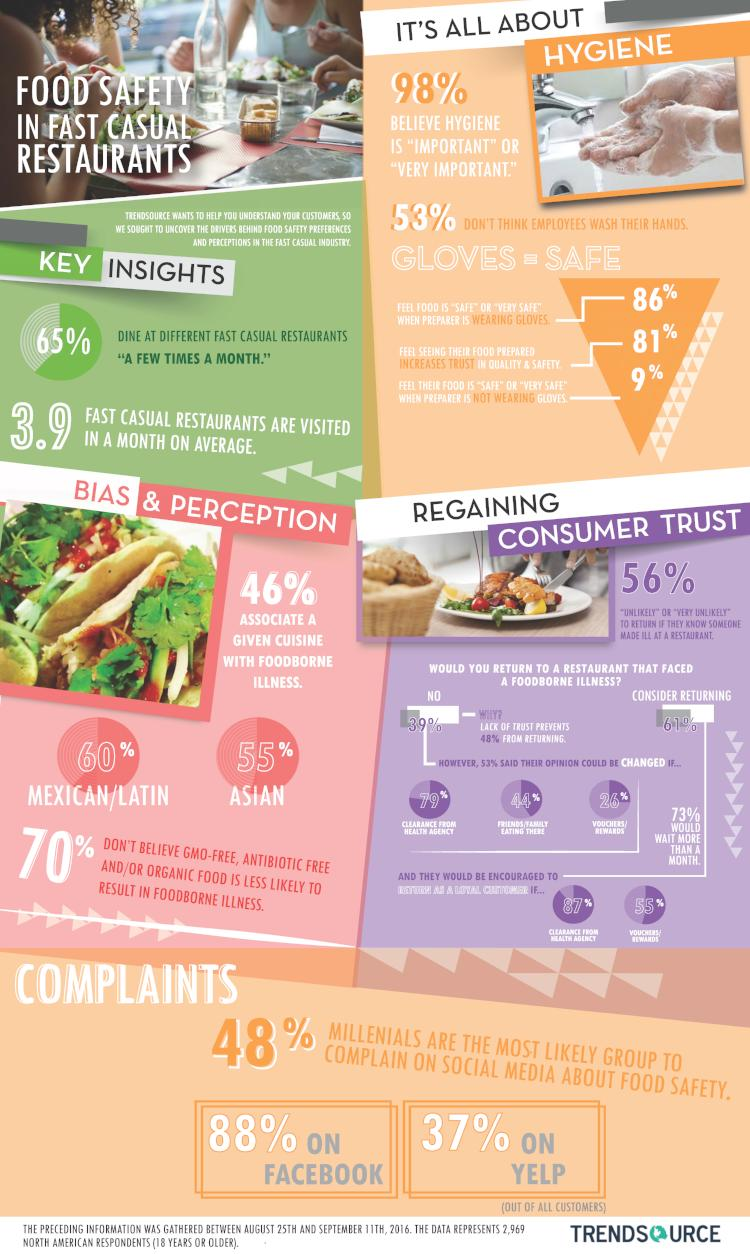Highlight a few significant elements in this photo. According to a survey, 60% of the people associate Mexican food with foodborne illness. According to the survey, 56% of the respondents indicated that they are unlikely to return to a restaurant if they know of any case of foodborne illness. According to a survey of customers, an overwhelming 98% believe that hygiene is very important. According to the survey, 55% of the people associate Asian food with foodborne illness. 